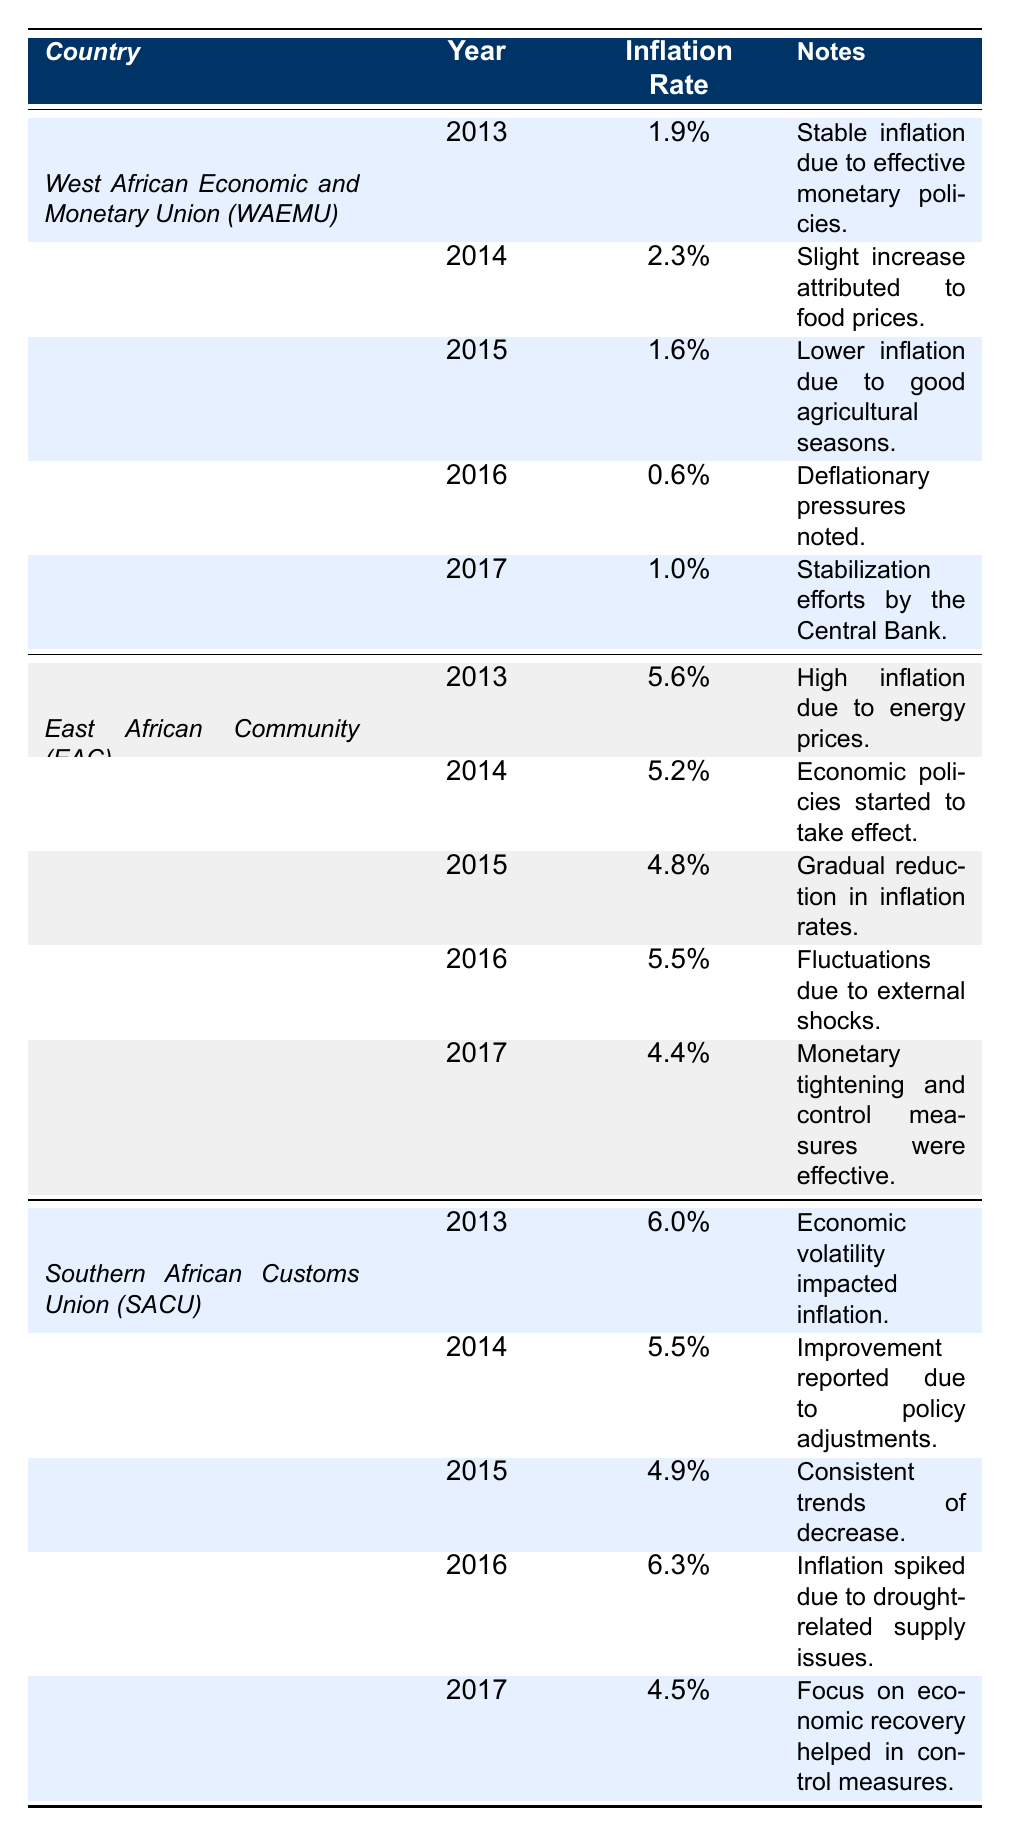What was the inflation rate in WAEMU in 2013? From the table, under the West African Economic and Monetary Union (WAEMU), the inflation rate for the year 2013 is listed as 1.9%.
Answer: 1.9% What was the highest inflation rate recorded in the East African Community from 2013 to 2017? Reviewing the inflation rates listed for the East African Community, the highest rate is 5.6% in 2013.
Answer: 5.6% Did inflation rates in WAEMU ever fall below 1% between 2013 and 2017? The inflation rates listed for WAEMU, from 2013 to 2017, do show that in 2016 it reached 0.6%, which is below 1%.
Answer: Yes What is the average inflation rate for the Southern African Customs Union from 2013 to 2017? To find the average, sum the inflation rates: (6.0 + 5.5 + 4.9 + 6.3 + 4.5) = 27.2%. Divide by 5 (the number of years): 27.2% / 5 = 5.44%.
Answer: 5.44% Which monetary union had the lowest inflation rate in any year from 2013 to 2017? From the data, WAEMU had the lowest inflation rate of 0.6% in 2016, which is lower than all other recorded rates for the other unions.
Answer: WAEMU in 2016 What trend is observed in the inflation rate of the East African Community from 2013 to 2017? By analyzing the inflation rates: 5.6% (2013), 5.2% (2014), 4.8% (2015), 5.5% (2016), and 4.4% (2017), it shows a general downward trend with slight fluctuations, particularly a peak in 2016.
Answer: Downward trend with fluctuations What year had the highest inflation in the Southern African Customs Union? Reviewing the SACU data, the highest inflation rate was 6.3%, noted in the year 2016.
Answer: 2016 